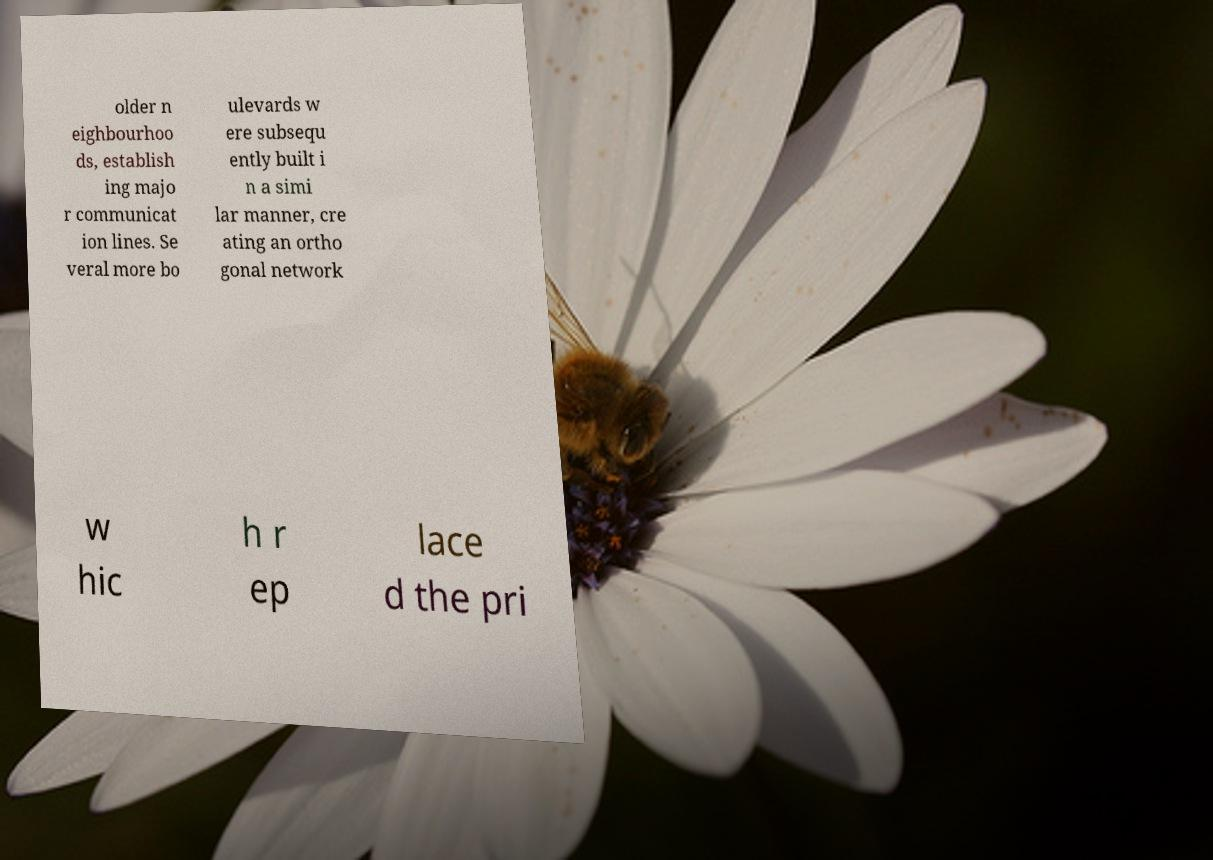For documentation purposes, I need the text within this image transcribed. Could you provide that? older n eighbourhoo ds, establish ing majo r communicat ion lines. Se veral more bo ulevards w ere subsequ ently built i n a simi lar manner, cre ating an ortho gonal network w hic h r ep lace d the pri 